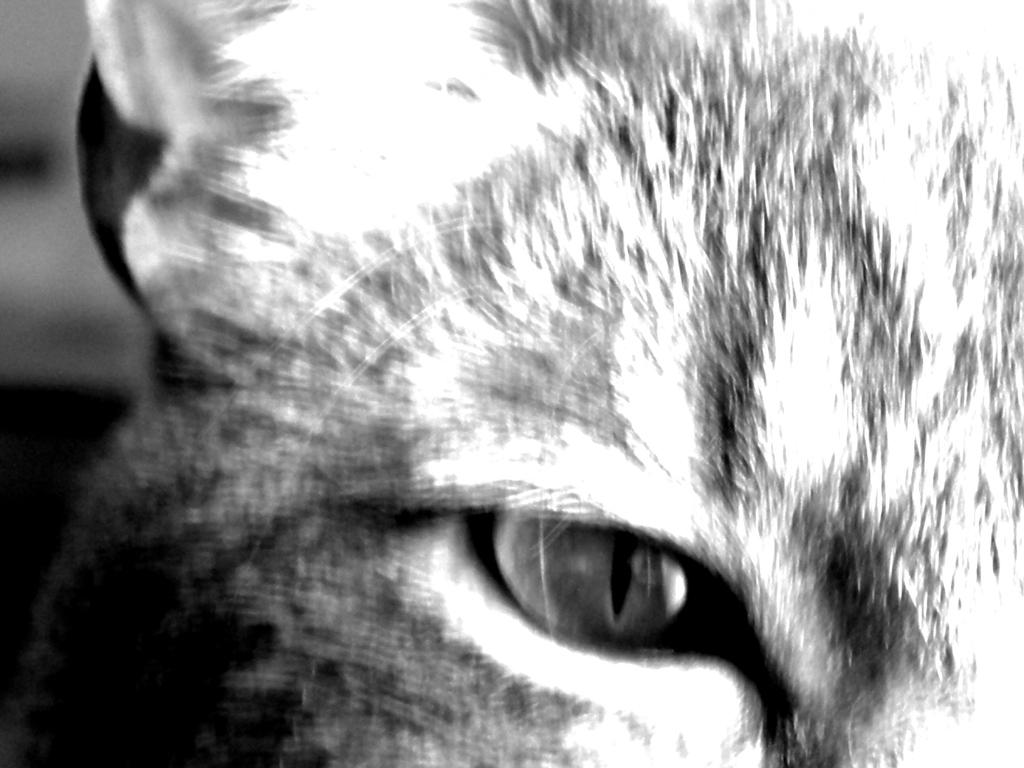What is the color scheme of the image? The image is black and white. What type of subject can be seen in the image? There is an animal in the image. What type of art is being displayed in the image? The image is not displaying any art; it is a photograph or illustration of an animal. Can you see the elbow of the animal in the image? The image does not show enough detail to determine if the animal has an elbow or not. 